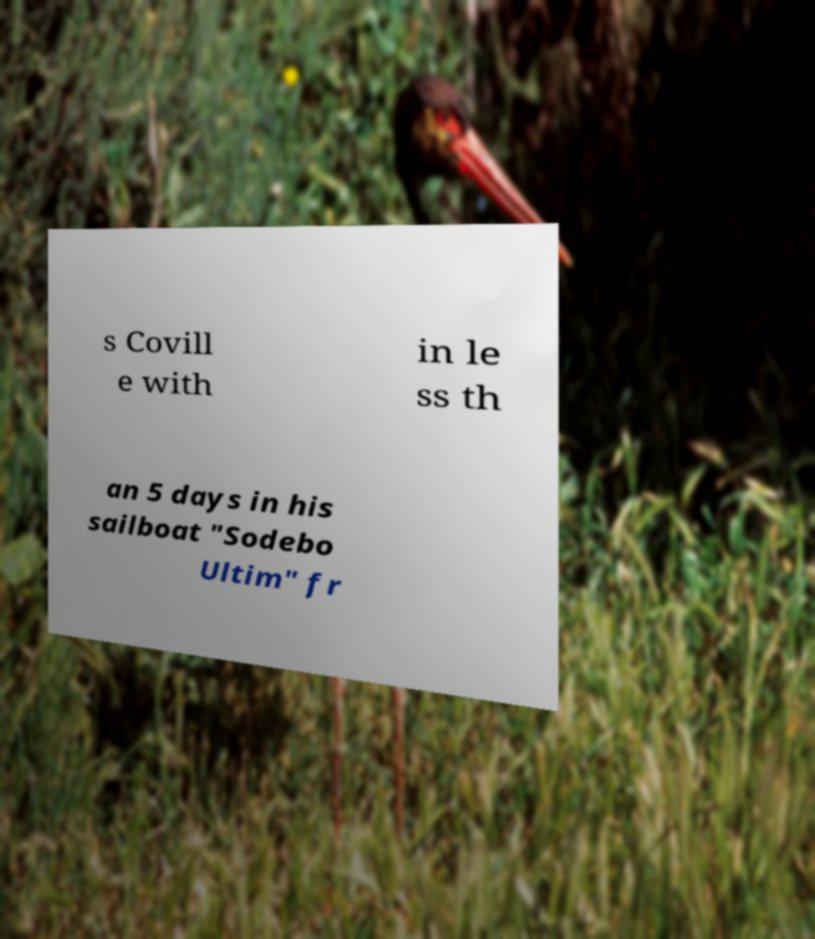There's text embedded in this image that I need extracted. Can you transcribe it verbatim? s Covill e with in le ss th an 5 days in his sailboat "Sodebo Ultim" fr 